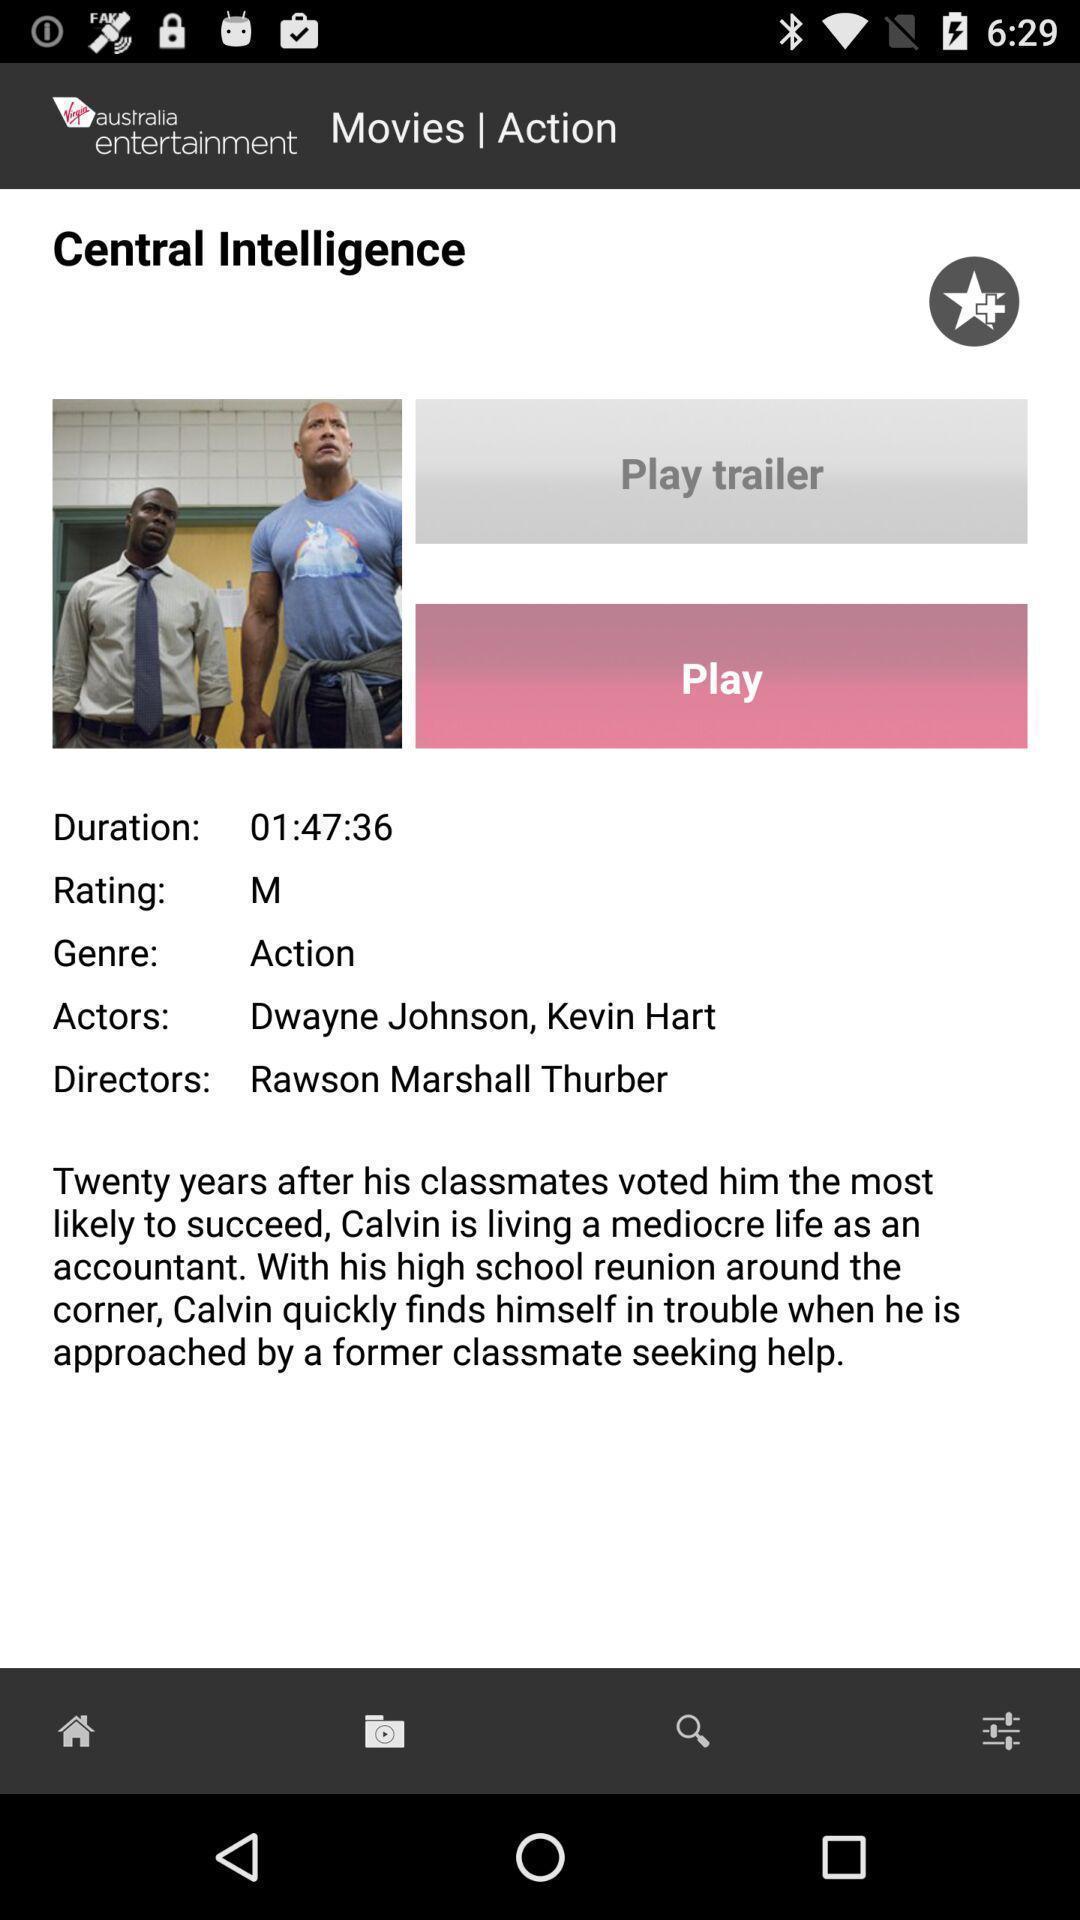Provide a textual representation of this image. Screen shows a movie to play. 